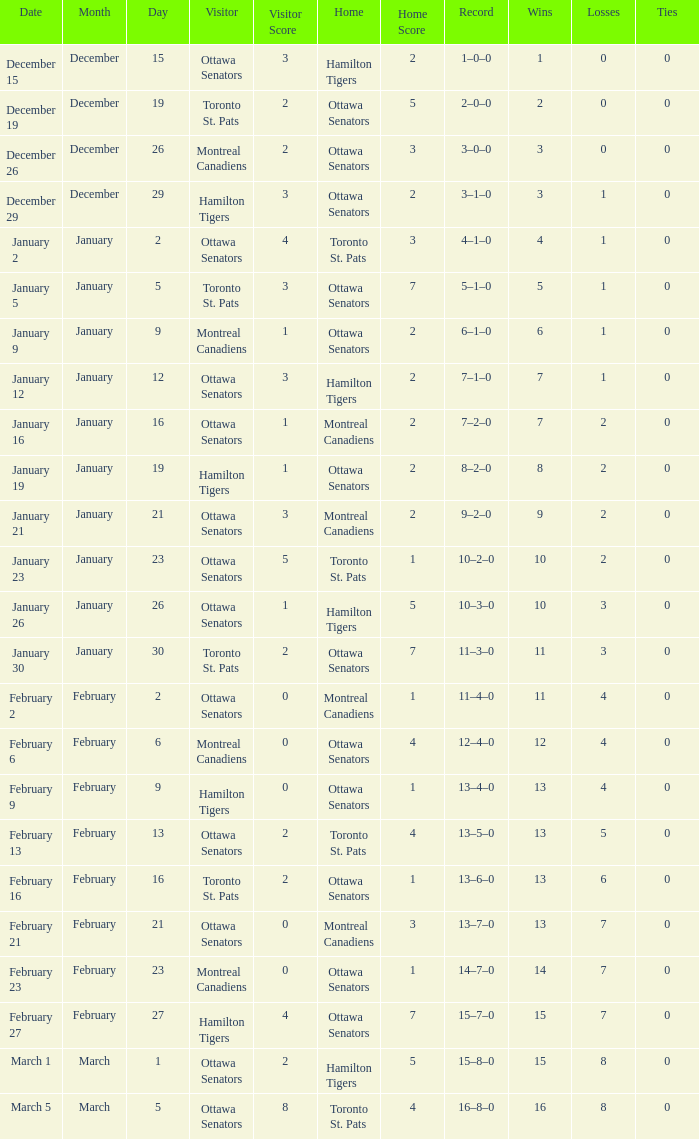In which game did the ottawa senators visit and the home team had a score of 1-5? Hamilton Tigers. 